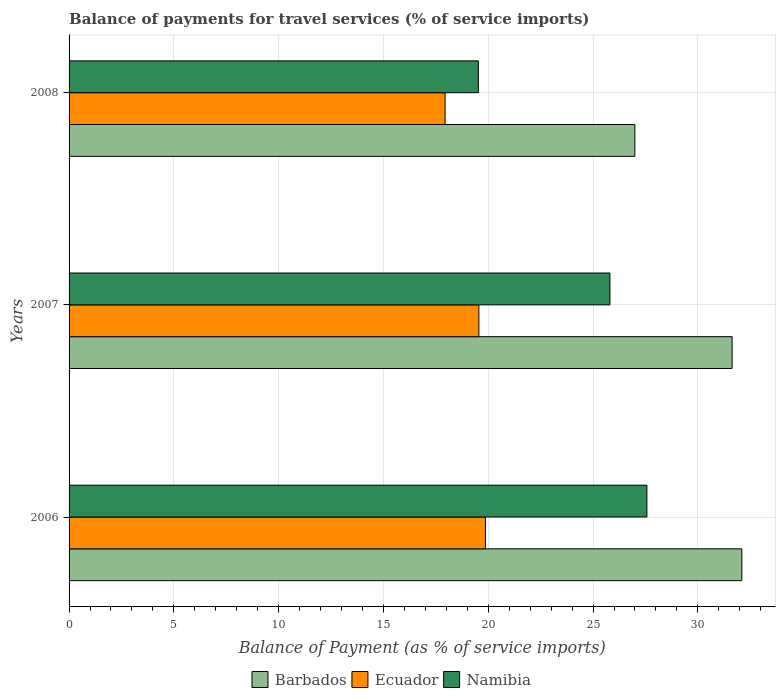How many bars are there on the 3rd tick from the top?
Provide a succinct answer. 3. How many bars are there on the 1st tick from the bottom?
Your answer should be very brief. 3. What is the label of the 2nd group of bars from the top?
Make the answer very short. 2007. What is the balance of payments for travel services in Barbados in 2007?
Your answer should be very brief. 31.64. Across all years, what is the maximum balance of payments for travel services in Barbados?
Provide a short and direct response. 32.1. Across all years, what is the minimum balance of payments for travel services in Ecuador?
Provide a succinct answer. 17.94. In which year was the balance of payments for travel services in Barbados maximum?
Offer a very short reply. 2006. What is the total balance of payments for travel services in Barbados in the graph?
Your response must be concise. 90.73. What is the difference between the balance of payments for travel services in Barbados in 2006 and that in 2007?
Provide a short and direct response. 0.47. What is the difference between the balance of payments for travel services in Namibia in 2006 and the balance of payments for travel services in Barbados in 2007?
Give a very brief answer. -4.06. What is the average balance of payments for travel services in Barbados per year?
Give a very brief answer. 30.24. In the year 2008, what is the difference between the balance of payments for travel services in Ecuador and balance of payments for travel services in Namibia?
Your answer should be very brief. -1.59. What is the ratio of the balance of payments for travel services in Namibia in 2006 to that in 2007?
Your response must be concise. 1.07. Is the difference between the balance of payments for travel services in Ecuador in 2006 and 2007 greater than the difference between the balance of payments for travel services in Namibia in 2006 and 2007?
Your response must be concise. No. What is the difference between the highest and the second highest balance of payments for travel services in Ecuador?
Your answer should be very brief. 0.31. What is the difference between the highest and the lowest balance of payments for travel services in Ecuador?
Your answer should be very brief. 1.92. What does the 2nd bar from the top in 2006 represents?
Make the answer very short. Ecuador. What does the 3rd bar from the bottom in 2008 represents?
Give a very brief answer. Namibia. Is it the case that in every year, the sum of the balance of payments for travel services in Namibia and balance of payments for travel services in Barbados is greater than the balance of payments for travel services in Ecuador?
Provide a succinct answer. Yes. How many bars are there?
Offer a very short reply. 9. How many years are there in the graph?
Provide a short and direct response. 3. Are the values on the major ticks of X-axis written in scientific E-notation?
Give a very brief answer. No. Does the graph contain grids?
Your answer should be compact. Yes. Where does the legend appear in the graph?
Your answer should be compact. Bottom center. How many legend labels are there?
Offer a terse response. 3. What is the title of the graph?
Offer a very short reply. Balance of payments for travel services (% of service imports). What is the label or title of the X-axis?
Ensure brevity in your answer.  Balance of Payment (as % of service imports). What is the label or title of the Y-axis?
Your response must be concise. Years. What is the Balance of Payment (as % of service imports) of Barbados in 2006?
Your answer should be very brief. 32.1. What is the Balance of Payment (as % of service imports) in Ecuador in 2006?
Provide a succinct answer. 19.87. What is the Balance of Payment (as % of service imports) of Namibia in 2006?
Provide a succinct answer. 27.57. What is the Balance of Payment (as % of service imports) in Barbados in 2007?
Give a very brief answer. 31.64. What is the Balance of Payment (as % of service imports) in Ecuador in 2007?
Your answer should be very brief. 19.55. What is the Balance of Payment (as % of service imports) of Namibia in 2007?
Make the answer very short. 25.81. What is the Balance of Payment (as % of service imports) in Barbados in 2008?
Ensure brevity in your answer.  26.99. What is the Balance of Payment (as % of service imports) of Ecuador in 2008?
Offer a terse response. 17.94. What is the Balance of Payment (as % of service imports) of Namibia in 2008?
Offer a very short reply. 19.53. Across all years, what is the maximum Balance of Payment (as % of service imports) of Barbados?
Keep it short and to the point. 32.1. Across all years, what is the maximum Balance of Payment (as % of service imports) in Ecuador?
Make the answer very short. 19.87. Across all years, what is the maximum Balance of Payment (as % of service imports) of Namibia?
Offer a very short reply. 27.57. Across all years, what is the minimum Balance of Payment (as % of service imports) in Barbados?
Ensure brevity in your answer.  26.99. Across all years, what is the minimum Balance of Payment (as % of service imports) in Ecuador?
Make the answer very short. 17.94. Across all years, what is the minimum Balance of Payment (as % of service imports) in Namibia?
Give a very brief answer. 19.53. What is the total Balance of Payment (as % of service imports) of Barbados in the graph?
Your answer should be very brief. 90.73. What is the total Balance of Payment (as % of service imports) of Ecuador in the graph?
Provide a succinct answer. 57.36. What is the total Balance of Payment (as % of service imports) in Namibia in the graph?
Keep it short and to the point. 72.9. What is the difference between the Balance of Payment (as % of service imports) of Barbados in 2006 and that in 2007?
Your answer should be compact. 0.47. What is the difference between the Balance of Payment (as % of service imports) of Ecuador in 2006 and that in 2007?
Provide a succinct answer. 0.31. What is the difference between the Balance of Payment (as % of service imports) in Namibia in 2006 and that in 2007?
Your response must be concise. 1.77. What is the difference between the Balance of Payment (as % of service imports) in Barbados in 2006 and that in 2008?
Provide a succinct answer. 5.11. What is the difference between the Balance of Payment (as % of service imports) of Ecuador in 2006 and that in 2008?
Offer a terse response. 1.92. What is the difference between the Balance of Payment (as % of service imports) in Namibia in 2006 and that in 2008?
Provide a short and direct response. 8.04. What is the difference between the Balance of Payment (as % of service imports) of Barbados in 2007 and that in 2008?
Ensure brevity in your answer.  4.64. What is the difference between the Balance of Payment (as % of service imports) of Ecuador in 2007 and that in 2008?
Provide a succinct answer. 1.61. What is the difference between the Balance of Payment (as % of service imports) of Namibia in 2007 and that in 2008?
Ensure brevity in your answer.  6.28. What is the difference between the Balance of Payment (as % of service imports) of Barbados in 2006 and the Balance of Payment (as % of service imports) of Ecuador in 2007?
Make the answer very short. 12.55. What is the difference between the Balance of Payment (as % of service imports) in Barbados in 2006 and the Balance of Payment (as % of service imports) in Namibia in 2007?
Offer a terse response. 6.3. What is the difference between the Balance of Payment (as % of service imports) of Ecuador in 2006 and the Balance of Payment (as % of service imports) of Namibia in 2007?
Your answer should be compact. -5.94. What is the difference between the Balance of Payment (as % of service imports) of Barbados in 2006 and the Balance of Payment (as % of service imports) of Ecuador in 2008?
Provide a succinct answer. 14.16. What is the difference between the Balance of Payment (as % of service imports) of Barbados in 2006 and the Balance of Payment (as % of service imports) of Namibia in 2008?
Offer a terse response. 12.57. What is the difference between the Balance of Payment (as % of service imports) of Ecuador in 2006 and the Balance of Payment (as % of service imports) of Namibia in 2008?
Make the answer very short. 0.34. What is the difference between the Balance of Payment (as % of service imports) in Barbados in 2007 and the Balance of Payment (as % of service imports) in Ecuador in 2008?
Your answer should be compact. 13.69. What is the difference between the Balance of Payment (as % of service imports) in Barbados in 2007 and the Balance of Payment (as % of service imports) in Namibia in 2008?
Provide a succinct answer. 12.11. What is the difference between the Balance of Payment (as % of service imports) in Ecuador in 2007 and the Balance of Payment (as % of service imports) in Namibia in 2008?
Your response must be concise. 0.02. What is the average Balance of Payment (as % of service imports) in Barbados per year?
Give a very brief answer. 30.24. What is the average Balance of Payment (as % of service imports) of Ecuador per year?
Provide a succinct answer. 19.12. What is the average Balance of Payment (as % of service imports) of Namibia per year?
Your response must be concise. 24.3. In the year 2006, what is the difference between the Balance of Payment (as % of service imports) of Barbados and Balance of Payment (as % of service imports) of Ecuador?
Your answer should be compact. 12.23. In the year 2006, what is the difference between the Balance of Payment (as % of service imports) of Barbados and Balance of Payment (as % of service imports) of Namibia?
Make the answer very short. 4.53. In the year 2006, what is the difference between the Balance of Payment (as % of service imports) in Ecuador and Balance of Payment (as % of service imports) in Namibia?
Make the answer very short. -7.7. In the year 2007, what is the difference between the Balance of Payment (as % of service imports) in Barbados and Balance of Payment (as % of service imports) in Ecuador?
Your answer should be very brief. 12.08. In the year 2007, what is the difference between the Balance of Payment (as % of service imports) of Barbados and Balance of Payment (as % of service imports) of Namibia?
Your response must be concise. 5.83. In the year 2007, what is the difference between the Balance of Payment (as % of service imports) of Ecuador and Balance of Payment (as % of service imports) of Namibia?
Your response must be concise. -6.25. In the year 2008, what is the difference between the Balance of Payment (as % of service imports) in Barbados and Balance of Payment (as % of service imports) in Ecuador?
Make the answer very short. 9.05. In the year 2008, what is the difference between the Balance of Payment (as % of service imports) of Barbados and Balance of Payment (as % of service imports) of Namibia?
Your response must be concise. 7.47. In the year 2008, what is the difference between the Balance of Payment (as % of service imports) in Ecuador and Balance of Payment (as % of service imports) in Namibia?
Offer a terse response. -1.59. What is the ratio of the Balance of Payment (as % of service imports) of Barbados in 2006 to that in 2007?
Your response must be concise. 1.01. What is the ratio of the Balance of Payment (as % of service imports) in Namibia in 2006 to that in 2007?
Give a very brief answer. 1.07. What is the ratio of the Balance of Payment (as % of service imports) of Barbados in 2006 to that in 2008?
Provide a succinct answer. 1.19. What is the ratio of the Balance of Payment (as % of service imports) of Ecuador in 2006 to that in 2008?
Give a very brief answer. 1.11. What is the ratio of the Balance of Payment (as % of service imports) in Namibia in 2006 to that in 2008?
Provide a short and direct response. 1.41. What is the ratio of the Balance of Payment (as % of service imports) in Barbados in 2007 to that in 2008?
Provide a short and direct response. 1.17. What is the ratio of the Balance of Payment (as % of service imports) in Ecuador in 2007 to that in 2008?
Provide a succinct answer. 1.09. What is the ratio of the Balance of Payment (as % of service imports) in Namibia in 2007 to that in 2008?
Provide a succinct answer. 1.32. What is the difference between the highest and the second highest Balance of Payment (as % of service imports) of Barbados?
Provide a succinct answer. 0.47. What is the difference between the highest and the second highest Balance of Payment (as % of service imports) of Ecuador?
Provide a short and direct response. 0.31. What is the difference between the highest and the second highest Balance of Payment (as % of service imports) of Namibia?
Your answer should be compact. 1.77. What is the difference between the highest and the lowest Balance of Payment (as % of service imports) of Barbados?
Your response must be concise. 5.11. What is the difference between the highest and the lowest Balance of Payment (as % of service imports) of Ecuador?
Provide a short and direct response. 1.92. What is the difference between the highest and the lowest Balance of Payment (as % of service imports) of Namibia?
Your answer should be very brief. 8.04. 